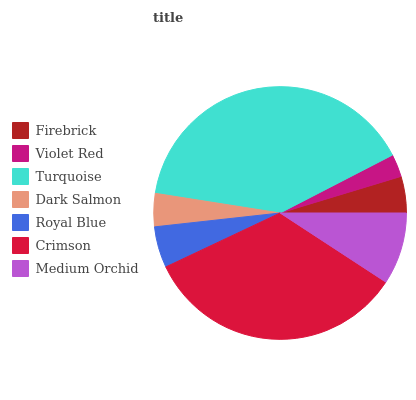Is Violet Red the minimum?
Answer yes or no. Yes. Is Turquoise the maximum?
Answer yes or no. Yes. Is Turquoise the minimum?
Answer yes or no. No. Is Violet Red the maximum?
Answer yes or no. No. Is Turquoise greater than Violet Red?
Answer yes or no. Yes. Is Violet Red less than Turquoise?
Answer yes or no. Yes. Is Violet Red greater than Turquoise?
Answer yes or no. No. Is Turquoise less than Violet Red?
Answer yes or no. No. Is Royal Blue the high median?
Answer yes or no. Yes. Is Royal Blue the low median?
Answer yes or no. Yes. Is Crimson the high median?
Answer yes or no. No. Is Crimson the low median?
Answer yes or no. No. 